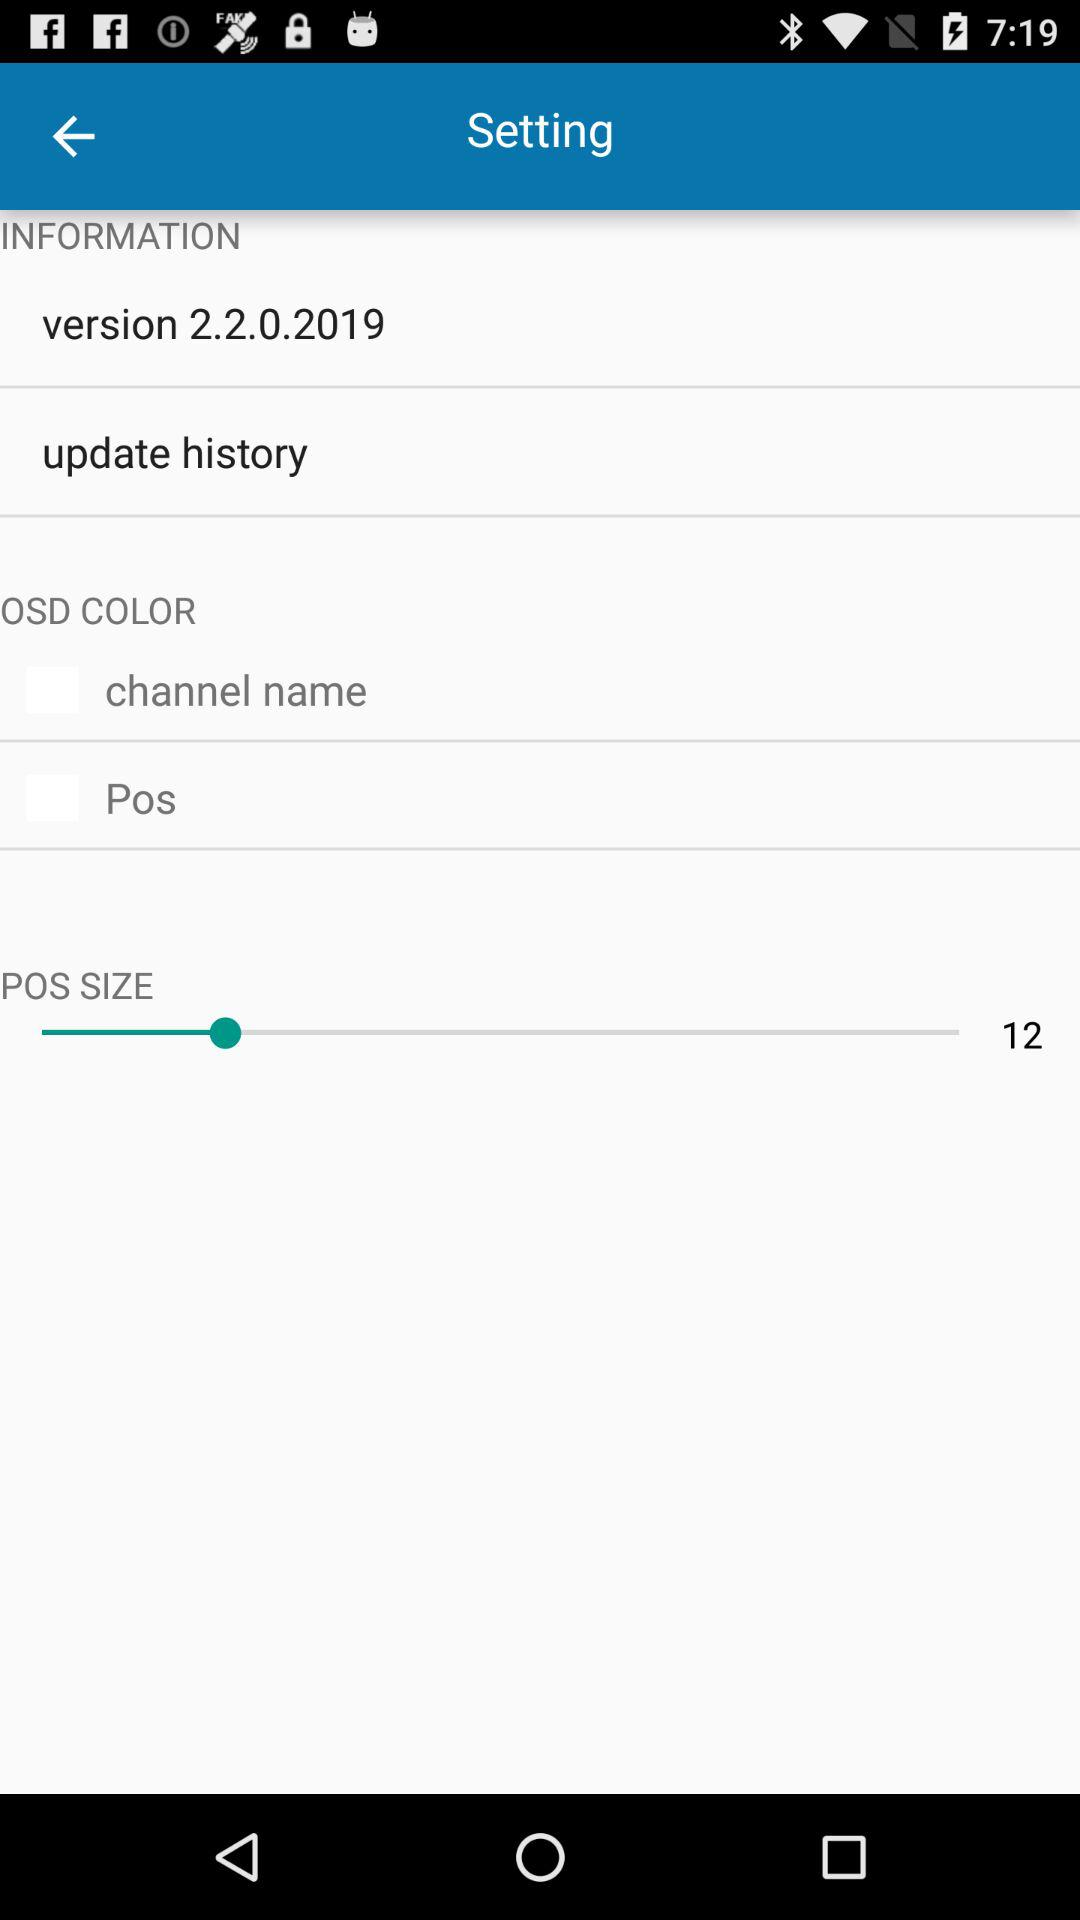What is the version of the application? The version of the application is 2.2.0.2019. 